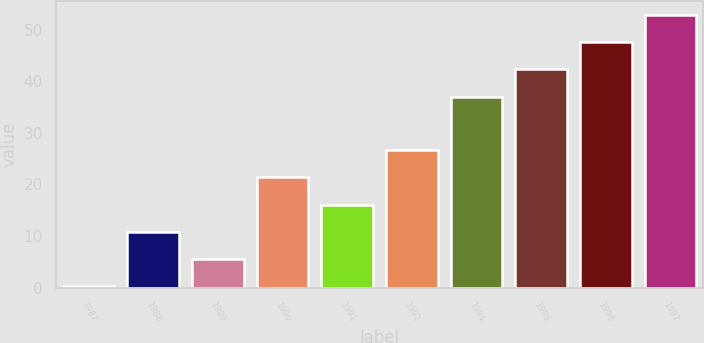Convert chart. <chart><loc_0><loc_0><loc_500><loc_500><bar_chart><fcel>1987<fcel>1988<fcel>1989<fcel>1990<fcel>1991<fcel>1992<fcel>1994<fcel>1995<fcel>1996<fcel>1997<nl><fcel>0.27<fcel>10.81<fcel>5.54<fcel>21.35<fcel>16.08<fcel>26.62<fcel>37<fcel>42.27<fcel>47.54<fcel>52.81<nl></chart> 